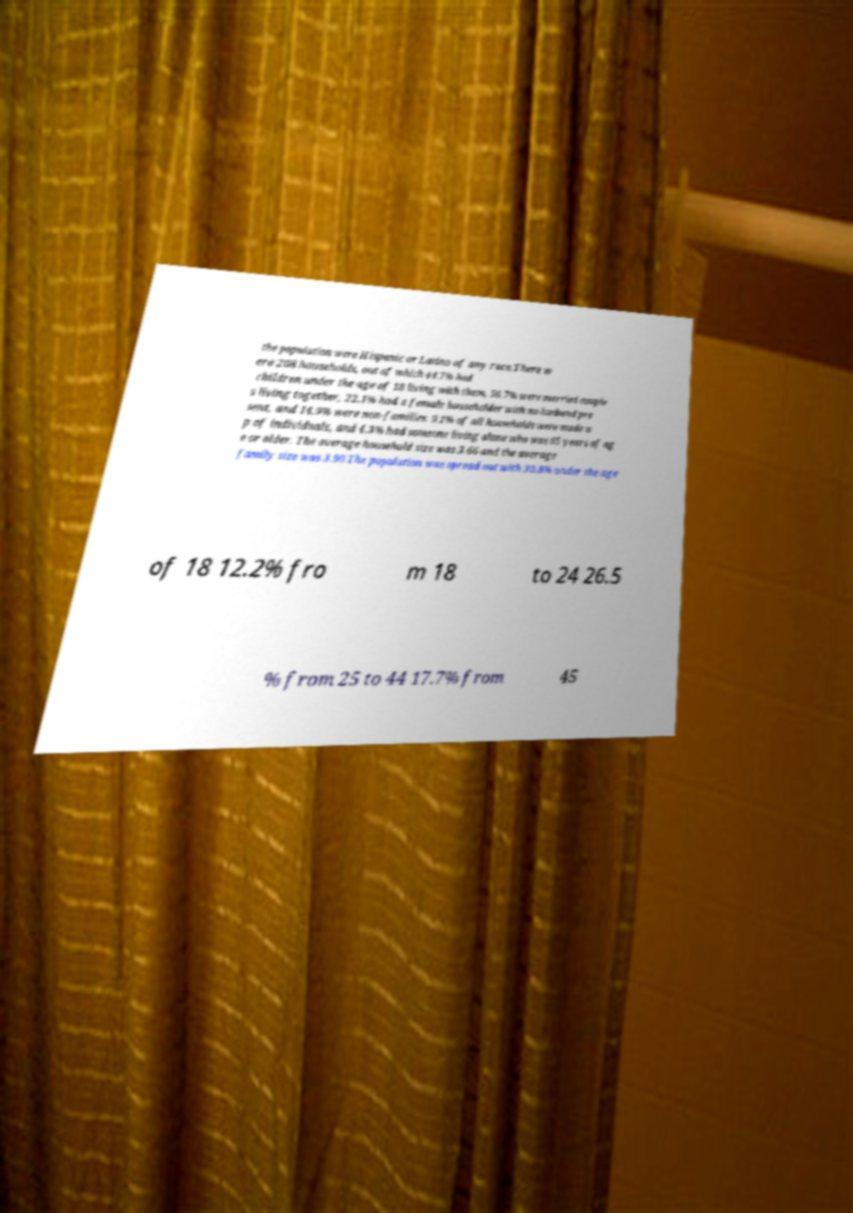For documentation purposes, I need the text within this image transcribed. Could you provide that? the population were Hispanic or Latino of any race.There w ere 208 households, out of which 44.7% had children under the age of 18 living with them, 56.7% were married couple s living together, 22.1% had a female householder with no husband pre sent, and 14.9% were non-families. 9.1% of all households were made u p of individuals, and 4.3% had someone living alone who was 65 years of ag e or older. The average household size was 3.66 and the average family size was 3.90.The population was spread out with 30.8% under the age of 18 12.2% fro m 18 to 24 26.5 % from 25 to 44 17.7% from 45 